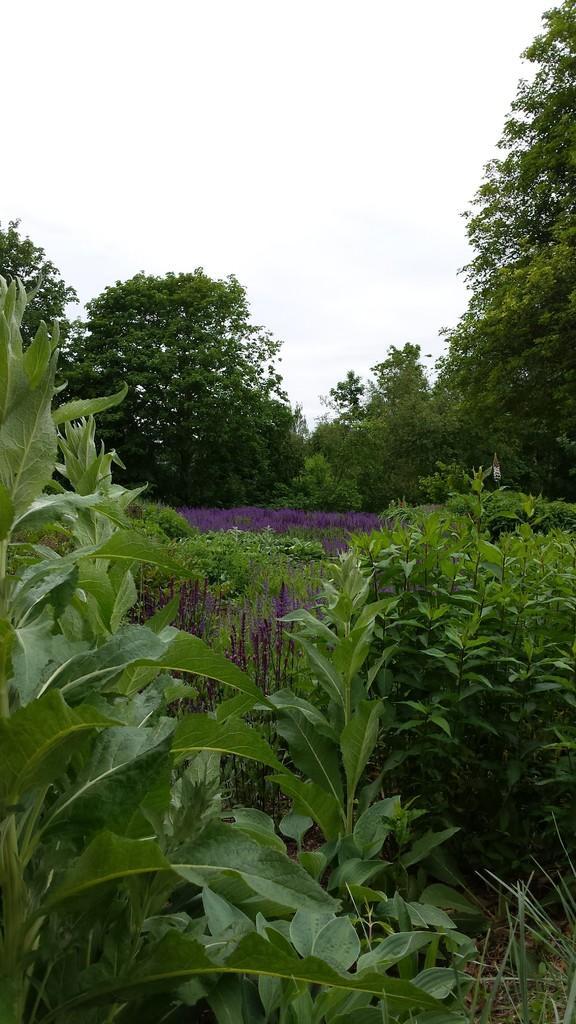Describe this image in one or two sentences. In this picture we can observe some plants on the ground. There are some trees. In the background there is a sky. 